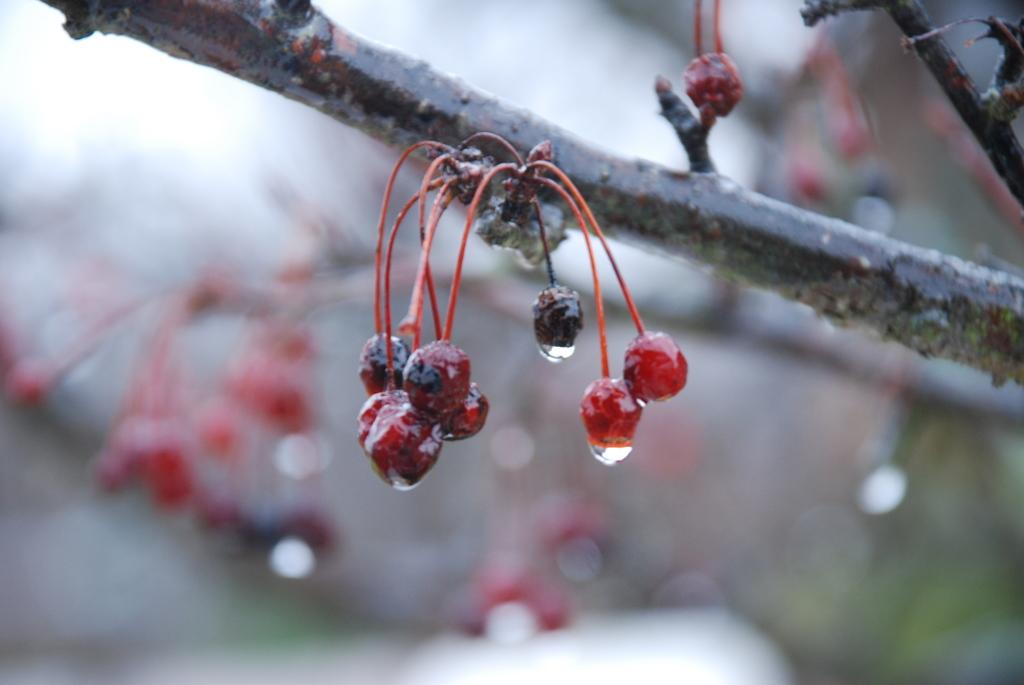What type of food can be seen in the image? There are fruits in the image. How are the fruits connected to each other? The fruits are attached to a stem. What colors are the fruits? The fruits have red and black colors. Can you describe the background of the image? The background of the image is blurred. Is the fruit expanding in the image? There is no indication of the fruit expanding in the image. 